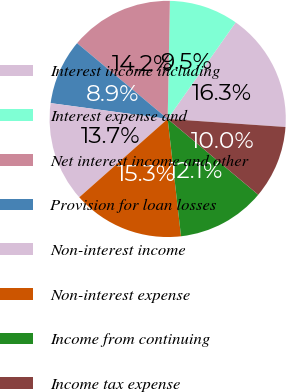<chart> <loc_0><loc_0><loc_500><loc_500><pie_chart><fcel>Interest income including<fcel>Interest expense and<fcel>Net interest income and other<fcel>Provision for loan losses<fcel>Non-interest income<fcel>Non-interest expense<fcel>Income from continuing<fcel>Income tax expense<nl><fcel>16.32%<fcel>9.47%<fcel>14.21%<fcel>8.95%<fcel>13.68%<fcel>15.26%<fcel>12.11%<fcel>10.0%<nl></chart> 